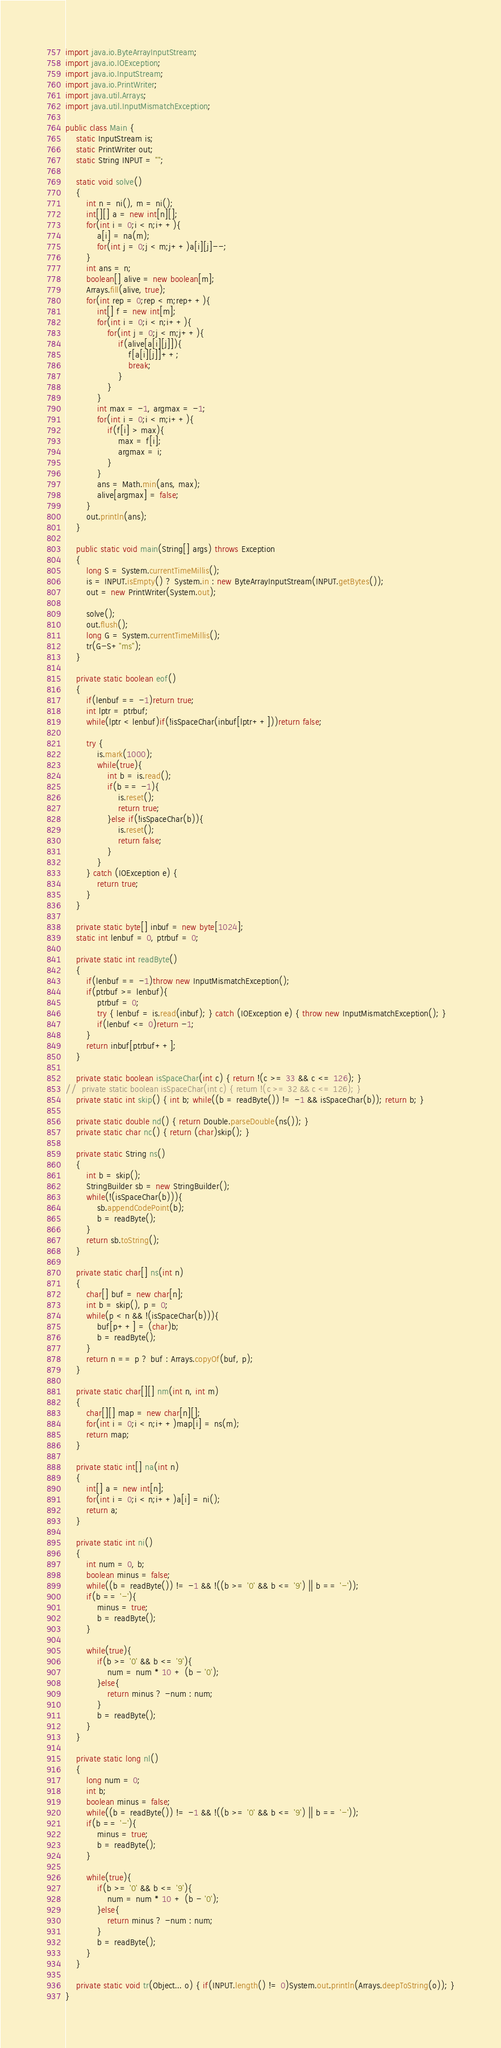Convert code to text. <code><loc_0><loc_0><loc_500><loc_500><_Java_>import java.io.ByteArrayInputStream;
import java.io.IOException;
import java.io.InputStream;
import java.io.PrintWriter;
import java.util.Arrays;
import java.util.InputMismatchException;

public class Main {
	static InputStream is;
	static PrintWriter out;
	static String INPUT = "";
	
	static void solve()
	{
		int n = ni(), m = ni();
		int[][] a = new int[n][];
		for(int i = 0;i < n;i++){
			a[i] = na(m);
			for(int j = 0;j < m;j++)a[i][j]--;
		}
		int ans = n;
		boolean[] alive = new boolean[m];
		Arrays.fill(alive, true);
		for(int rep = 0;rep < m;rep++){
			int[] f = new int[m];
			for(int i = 0;i < n;i++){
				for(int j = 0;j < m;j++){
					if(alive[a[i][j]]){
						f[a[i][j]]++;
						break;
					}
				}
			}
			int max = -1, argmax = -1;
			for(int i = 0;i < m;i++){
				if(f[i] > max){
					max = f[i];
					argmax = i;
				}
			}
			ans = Math.min(ans, max);
			alive[argmax] = false;
		}
		out.println(ans);
	}
	
	public static void main(String[] args) throws Exception
	{
		long S = System.currentTimeMillis();
		is = INPUT.isEmpty() ? System.in : new ByteArrayInputStream(INPUT.getBytes());
		out = new PrintWriter(System.out);
		
		solve();
		out.flush();
		long G = System.currentTimeMillis();
		tr(G-S+"ms");
	}
	
	private static boolean eof()
	{
		if(lenbuf == -1)return true;
		int lptr = ptrbuf;
		while(lptr < lenbuf)if(!isSpaceChar(inbuf[lptr++]))return false;
		
		try {
			is.mark(1000);
			while(true){
				int b = is.read();
				if(b == -1){
					is.reset();
					return true;
				}else if(!isSpaceChar(b)){
					is.reset();
					return false;
				}
			}
		} catch (IOException e) {
			return true;
		}
	}
	
	private static byte[] inbuf = new byte[1024];
	static int lenbuf = 0, ptrbuf = 0;
	
	private static int readByte()
	{
		if(lenbuf == -1)throw new InputMismatchException();
		if(ptrbuf >= lenbuf){
			ptrbuf = 0;
			try { lenbuf = is.read(inbuf); } catch (IOException e) { throw new InputMismatchException(); }
			if(lenbuf <= 0)return -1;
		}
		return inbuf[ptrbuf++];
	}
	
	private static boolean isSpaceChar(int c) { return !(c >= 33 && c <= 126); }
//	private static boolean isSpaceChar(int c) { return !(c >= 32 && c <= 126); }
	private static int skip() { int b; while((b = readByte()) != -1 && isSpaceChar(b)); return b; }
	
	private static double nd() { return Double.parseDouble(ns()); }
	private static char nc() { return (char)skip(); }
	
	private static String ns()
	{
		int b = skip();
		StringBuilder sb = new StringBuilder();
		while(!(isSpaceChar(b))){
			sb.appendCodePoint(b);
			b = readByte();
		}
		return sb.toString();
	}
	
	private static char[] ns(int n)
	{
		char[] buf = new char[n];
		int b = skip(), p = 0;
		while(p < n && !(isSpaceChar(b))){
			buf[p++] = (char)b;
			b = readByte();
		}
		return n == p ? buf : Arrays.copyOf(buf, p);
	}
	
	private static char[][] nm(int n, int m)
	{
		char[][] map = new char[n][];
		for(int i = 0;i < n;i++)map[i] = ns(m);
		return map;
	}
	
	private static int[] na(int n)
	{
		int[] a = new int[n];
		for(int i = 0;i < n;i++)a[i] = ni();
		return a;
	}
	
	private static int ni()
	{
		int num = 0, b;
		boolean minus = false;
		while((b = readByte()) != -1 && !((b >= '0' && b <= '9') || b == '-'));
		if(b == '-'){
			minus = true;
			b = readByte();
		}
		
		while(true){
			if(b >= '0' && b <= '9'){
				num = num * 10 + (b - '0');
			}else{
				return minus ? -num : num;
			}
			b = readByte();
		}
	}
	
	private static long nl()
	{
		long num = 0;
		int b;
		boolean minus = false;
		while((b = readByte()) != -1 && !((b >= '0' && b <= '9') || b == '-'));
		if(b == '-'){
			minus = true;
			b = readByte();
		}
		
		while(true){
			if(b >= '0' && b <= '9'){
				num = num * 10 + (b - '0');
			}else{
				return minus ? -num : num;
			}
			b = readByte();
		}
	}
	
	private static void tr(Object... o) { if(INPUT.length() != 0)System.out.println(Arrays.deepToString(o)); }
}
</code> 